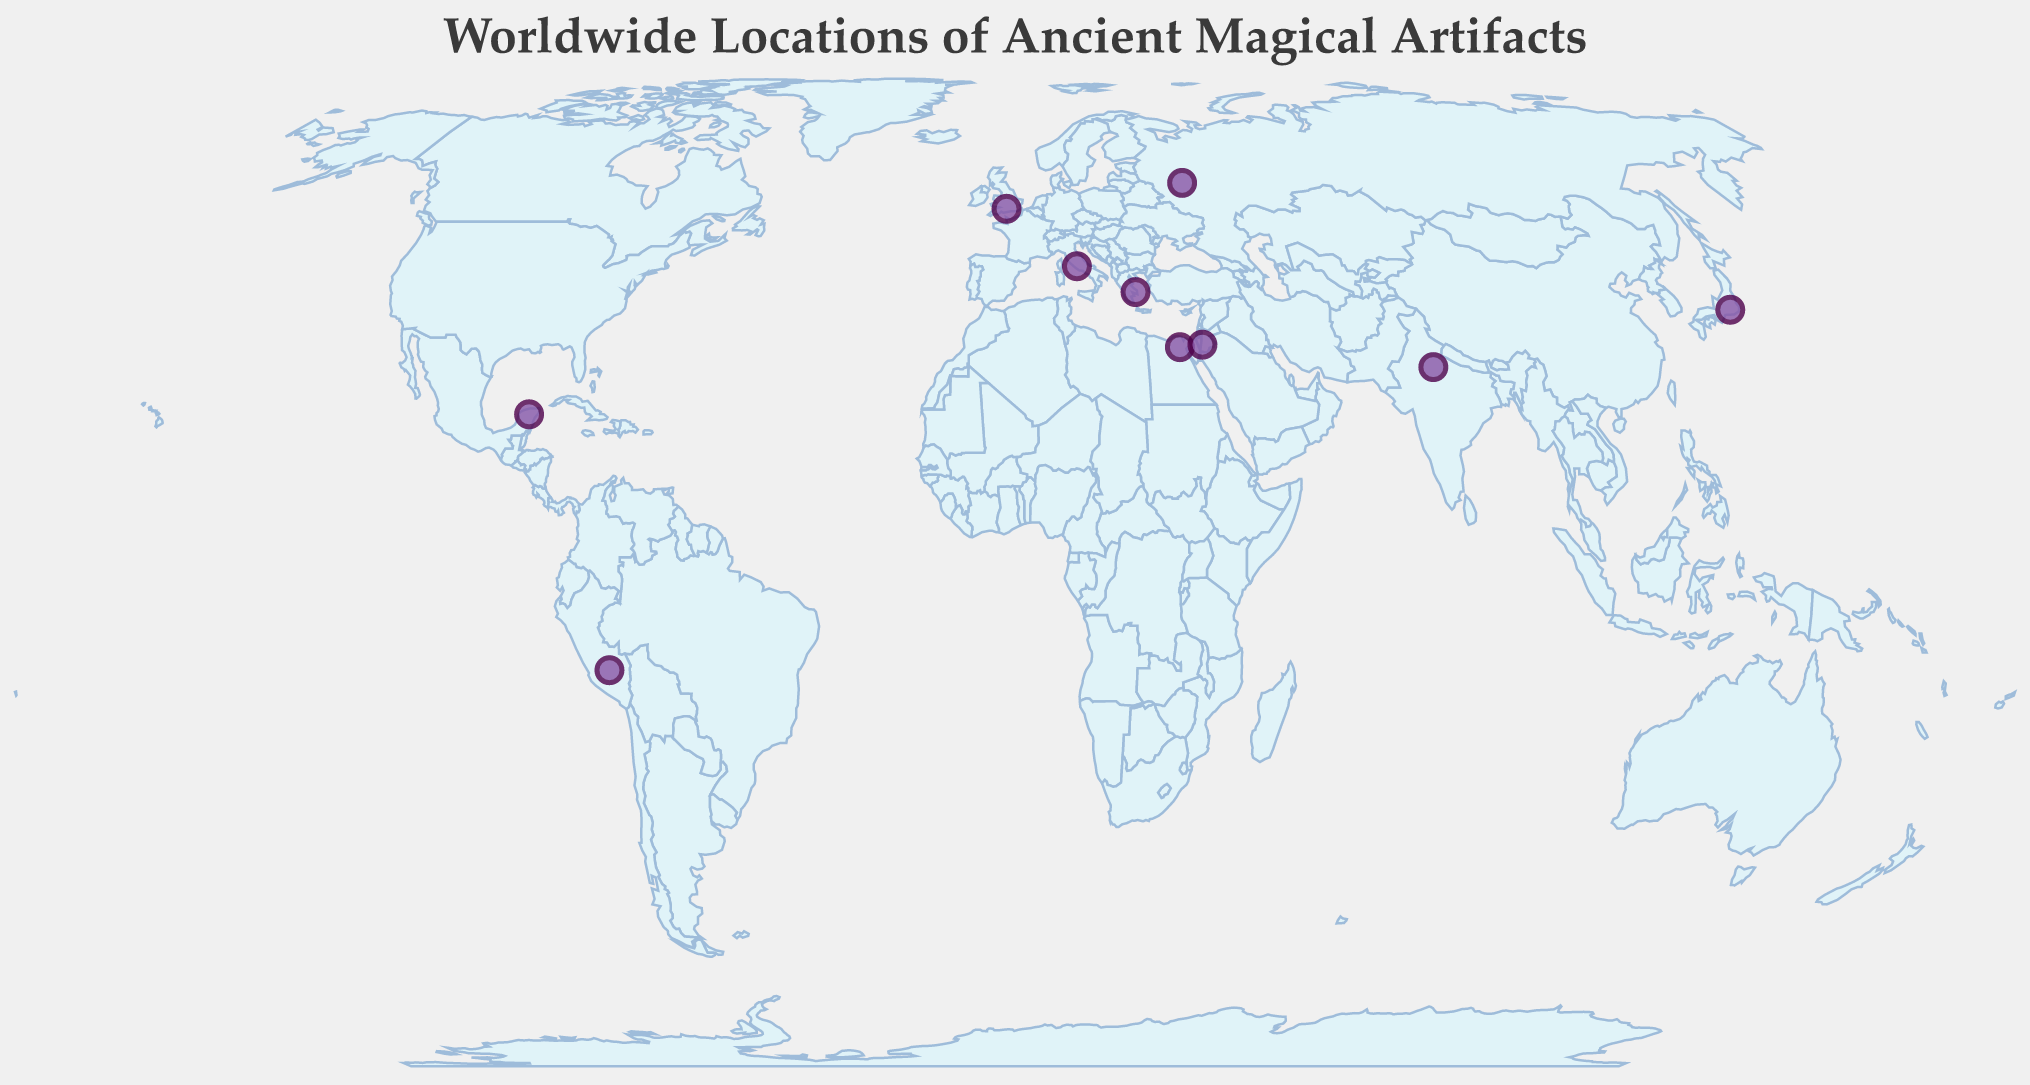What is the title of the plot? The title is prominently displayed at the top of the plot.
Answer: Worldwide Locations of Ancient Magical Artifacts How many artifacts are displayed on the map? Count the number of points (circles) plotted on the map corresponding to the artifacts.
Answer: 10 Which artifact is located at the coordinates (41.8902,12.4922)? Identify the artifact using the given latitude and longitude values.
Answer: Colosseum What type of power is associated with the Great Pyramid of Giza? Locate the Great Pyramid of Giza on the map and check its tooltip for the power information.
Answer: Teleportation Which two artifacts are located nearest to each other? Compare the distances between all pairs of artifacts on the map visually; the two closest points are noticeable.
Answer: Great Pyramid of Giza and Petra Which artifact is associated with the power of Mind Control? Identify the artifact by looking at the tooltip information for each artifact's power on the map.
Answer: Kremlin How many artifacts are located in the Northern Hemisphere? Count the number of artifacts with a positive latitude on the map.
Answer: 8 Which artifact is located furthest to the south? Locate the artifact with the smallest (most negative) latitude.
Answer: Machu Picchu Are there any artifacts located on the same continent? Visually inspect the map and group artifacts based on their continent. Multiple artifacts in Europe can easily be identified.
Answer: Yes What is the median latitude of the artifacts? List the latitudes, order them, and find the middle value. Latitudes: -13.1631, 20.6843, 27.1751, 29.9792, 30.3285, 35.3606, 37.9715, 41.8902, 51.1789, 55.752. The median is the average of the 5th and 6th values.
Answer: 30.34435 